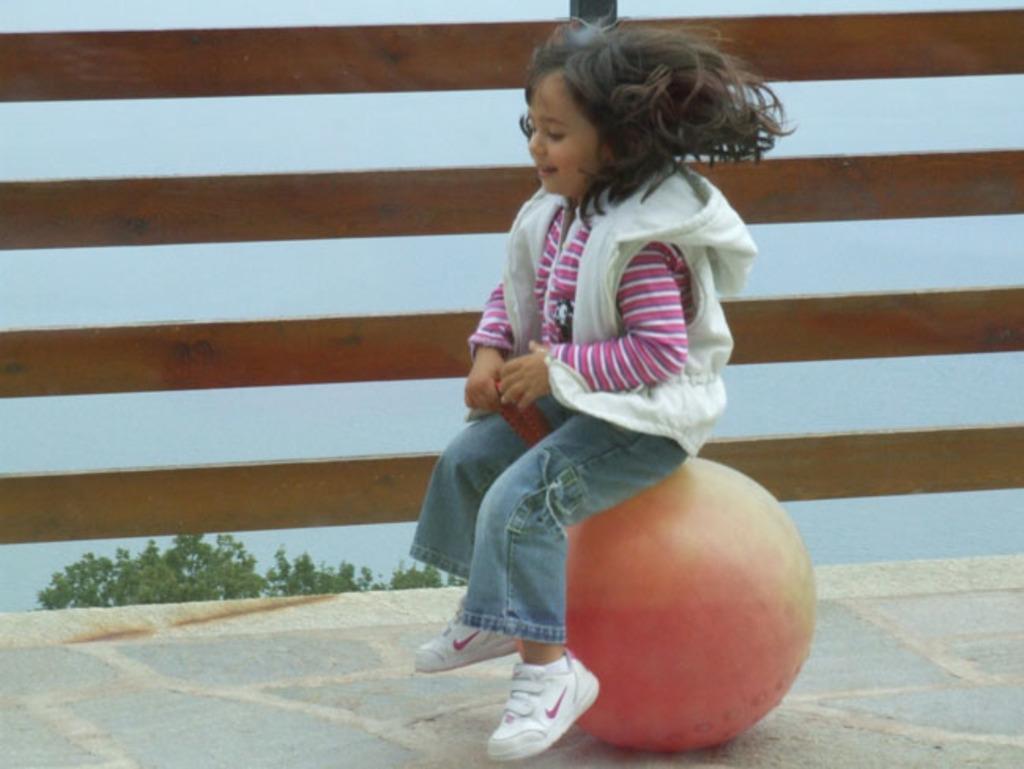Please provide a concise description of this image. In this picture we can see a girl is sitting on a round shaped object. Behind the girl there is a wooden fence, tree and the sky. 